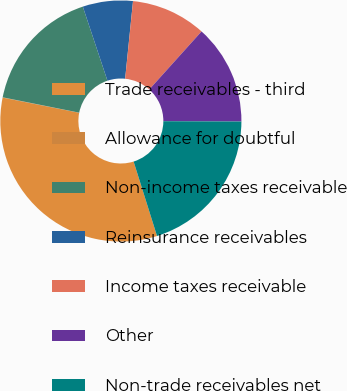Convert chart. <chart><loc_0><loc_0><loc_500><loc_500><pie_chart><fcel>Trade receivables - third<fcel>Allowance for doubtful<fcel>Non-income taxes receivable<fcel>Reinsurance receivables<fcel>Income taxes receivable<fcel>Other<fcel>Non-trade receivables net<nl><fcel>32.96%<fcel>0.04%<fcel>16.74%<fcel>6.72%<fcel>10.06%<fcel>13.4%<fcel>20.08%<nl></chart> 